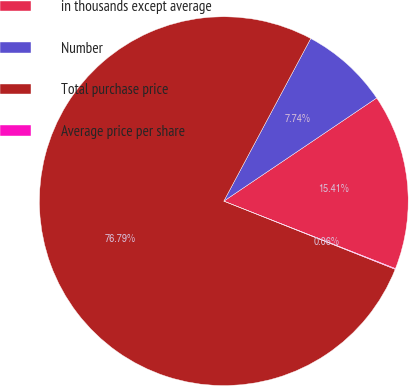Convert chart to OTSL. <chart><loc_0><loc_0><loc_500><loc_500><pie_chart><fcel>in thousands except average<fcel>Number<fcel>Total purchase price<fcel>Average price per share<nl><fcel>15.41%<fcel>7.74%<fcel>76.79%<fcel>0.06%<nl></chart> 